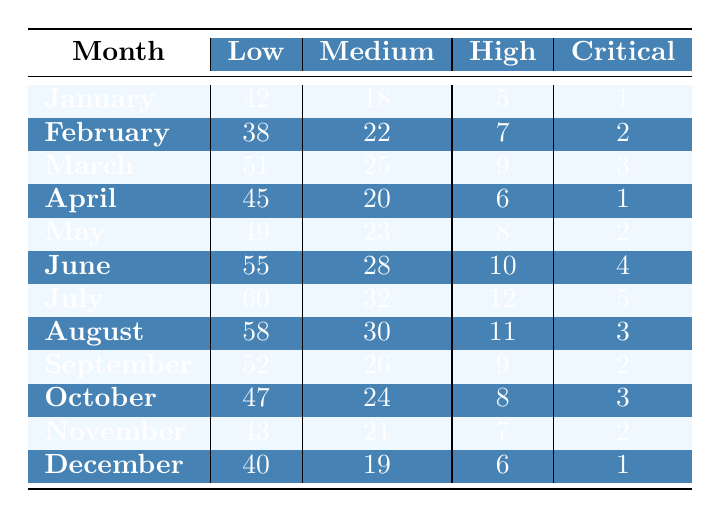What is the total number of security incidents in April? In April, the incidents are as follows: Low: 45, Medium: 20, High: 6, and Critical: 1. To find the total, add these numbers: 45 + 20 + 6 + 1 = 72.
Answer: 72 Which month had the highest number of critical severity incidents? By looking at the CriticalSeverity column, July has the highest number with 5 incidents, compared to the others.
Answer: July What is the average number of medium severity incidents across all months? To find the average, first sum the MediumSeverity values for each month: (18 + 22 + 25 + 20 + 23 + 28 + 32 + 30 + 26 + 24 + 21 + 19) =  25. Then divide by the number of months, which is 12. So the average is 25/12 ≈ 24.17.
Answer: 24.17 How many low severity incidents occurred in June and July combined? In June, there were 55 low severity incidents, and in July, there were 60. Adding these together gives us 55 + 60 = 115.
Answer: 115 In which month did the number of high severity incidents first exceed 10? The number of high severity incidents becomes 11 in August. Looking at earlier months, the highest was 10 in June. So August is the first month where it exceeds 10.
Answer: August Is there a trend indicating an increase or a decrease in critical severity incidents over the year? Evaluating the data, the critical incidents show 1, 2, 3, 1, 2, 4, 5, 3, 2, 3, 2, 1, which indicates fluctuations. However, the peak is in July, followed by a decrease. Therefore, there isn't a consistent trend.
Answer: No consistent trend What percentage of total incidents in December were of low severity? In December, the incidents are Low: 40, Medium: 19, High: 6, Critical: 1. The total incidents are 40 + 19 + 6 + 1 = 66. The low severity percentage is (40/66) * 100 ≈ 60.61%.
Answer: 60.61% Which month had the lowest count of medium severity incidents? Checking the MediumSeverity counts, the minimum occurs in January with 18 medium severity incidents, which is less than the other months.
Answer: January 